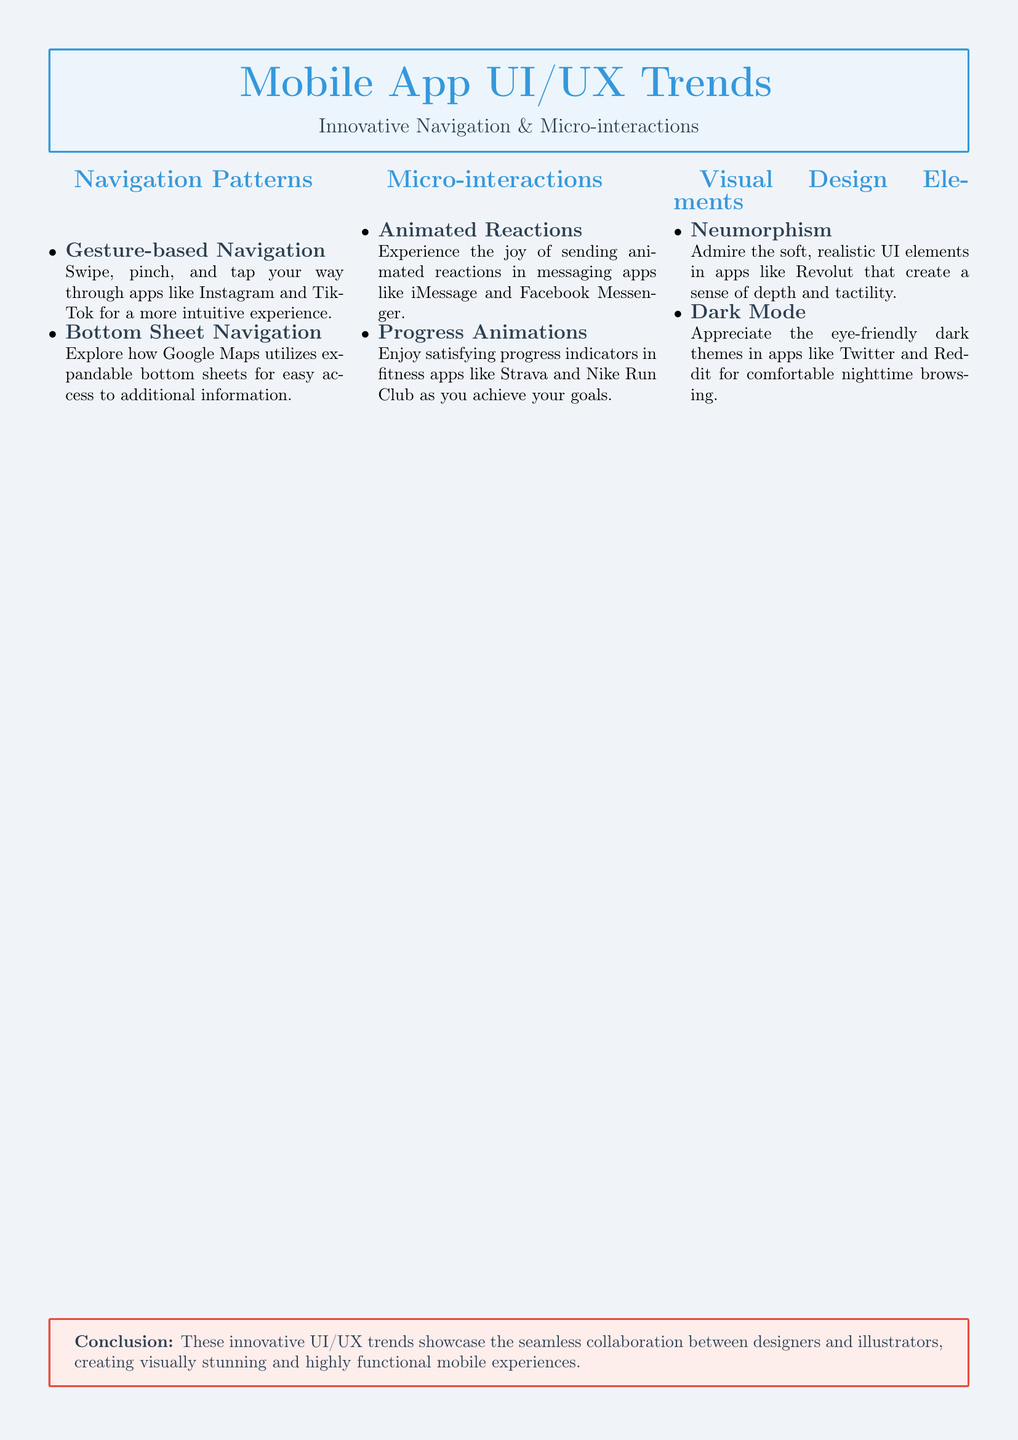what is the title of the document? The title is presented prominently at the beginning of the document, detailing the main focus.
Answer: Mobile App UI/UX Trends how many main sections are in the document? The document is divided into three main sections: Navigation Patterns, Micro-interactions, and Visual Design Elements.
Answer: 3 which app is mentioned for Gesture-based Navigation? The document refers to apps that utilize this navigation pattern, specifically citing an example for clarity.
Answer: Instagram what design trend features soft, realistic UI elements? This trend is highlighted in the visual design elements section as creating a unique aesthetic.
Answer: Neumorphism name one app noted for using Dark Mode? Dark Mode is associated with several apps in the document as an important visual option for users.
Answer: Twitter which section discusses progress animations? This section specifically addresses a variety of micro-interactions that enhance user engagement.
Answer: Micro-interactions which color is used for the primary design elements? The document uses specific colors throughout, making it visually appealing and cohesive.
Answer: #3498DB what is the conclusion about the collaboration in the document? The conclusion summarizes the main theme regarding the interplay of design roles in creating effective experiences.
Answer: Seamless collaboration between designers and illustrators 